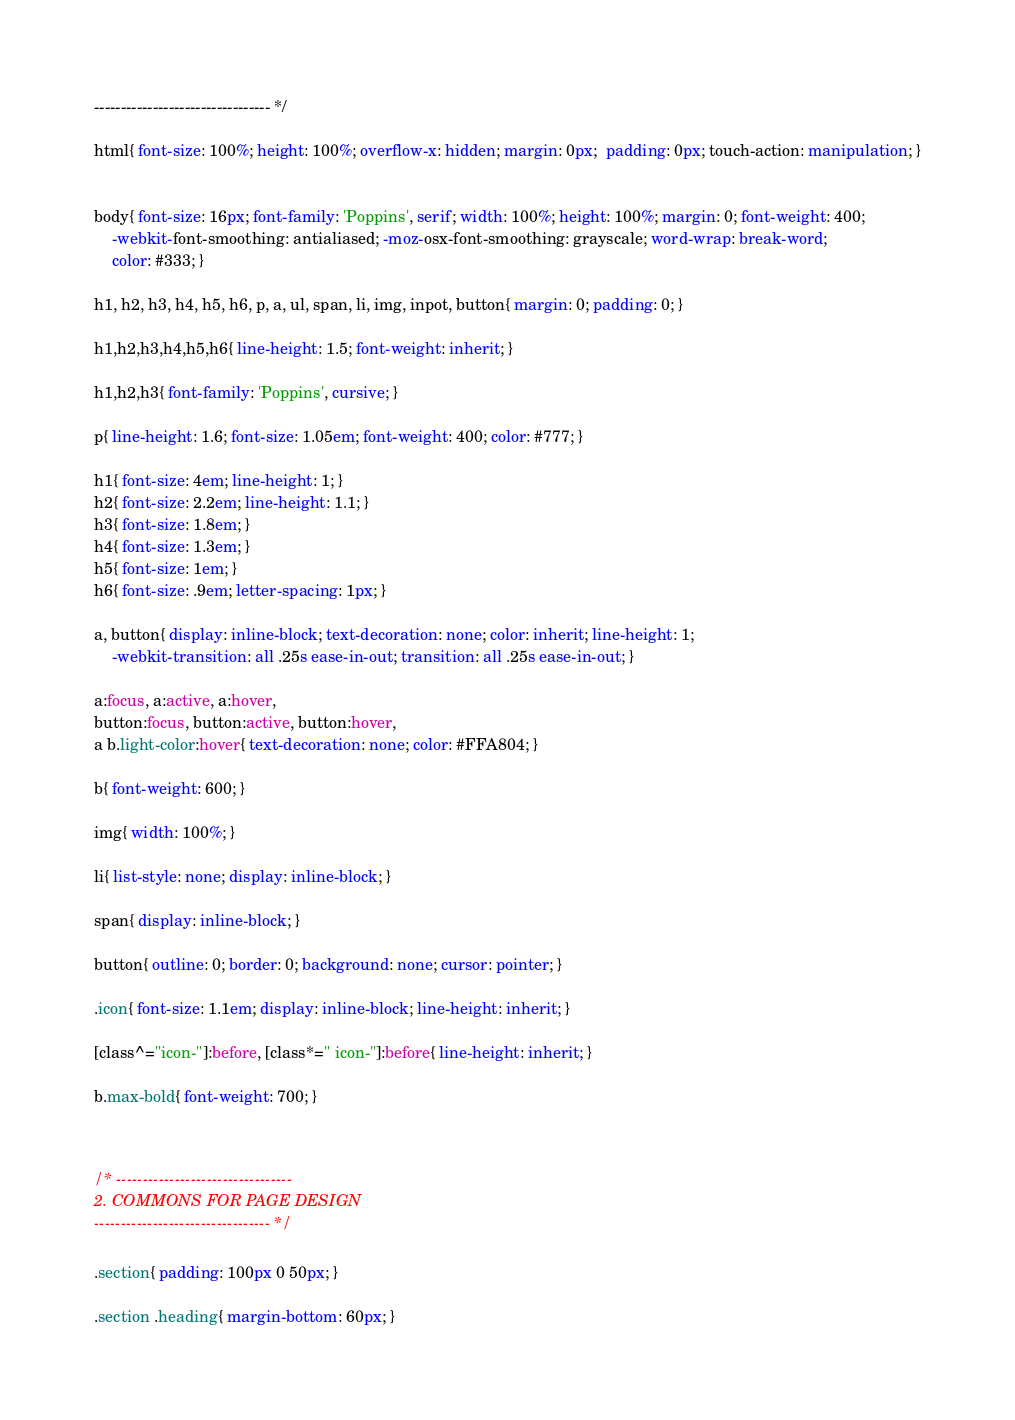Convert code to text. <code><loc_0><loc_0><loc_500><loc_500><_CSS_>--------------------------------- */

html{ font-size: 100%; height: 100%; overflow-x: hidden; margin: 0px;  padding: 0px; touch-action: manipulation; }


body{ font-size: 16px; font-family: 'Poppins', serif; width: 100%; height: 100%; margin: 0; font-weight: 400;
	-webkit-font-smoothing: antialiased; -moz-osx-font-smoothing: grayscale; word-wrap: break-word; 
	color: #333; }

h1, h2, h3, h4, h5, h6, p, a, ul, span, li, img, inpot, button{ margin: 0; padding: 0; }

h1,h2,h3,h4,h5,h6{ line-height: 1.5; font-weight: inherit; }

h1,h2,h3{ font-family: 'Poppins', cursive; }

p{ line-height: 1.6; font-size: 1.05em; font-weight: 400; color: #777; }

h1{ font-size: 4em; line-height: 1; }
h2{ font-size: 2.2em; line-height: 1.1; }
h3{ font-size: 1.8em; }
h4{ font-size: 1.3em; }
h5{ font-size: 1em; }
h6{ font-size: .9em; letter-spacing: 1px; }

a, button{ display: inline-block; text-decoration: none; color: inherit; line-height: 1; 
	-webkit-transition: all .25s ease-in-out; transition: all .25s ease-in-out; }

a:focus, a:active, a:hover,
button:focus, button:active, button:hover,
a b.light-color:hover{ text-decoration: none; color: #FFA804; }

b{ font-weight: 600; }

img{ width: 100%; }

li{ list-style: none; display: inline-block; }

span{ display: inline-block; }

button{ outline: 0; border: 0; background: none; cursor: pointer; }

.icon{ font-size: 1.1em; display: inline-block; line-height: inherit; }

[class^="icon-"]:before, [class*=" icon-"]:before{ line-height: inherit; }

b.max-bold{ font-weight: 700; }



/* ---------------------------------
2. COMMONS FOR PAGE DESIGN
--------------------------------- */

.section{ padding: 100px 0 50px; }

.section .heading{ margin-bottom: 60px; }
</code> 